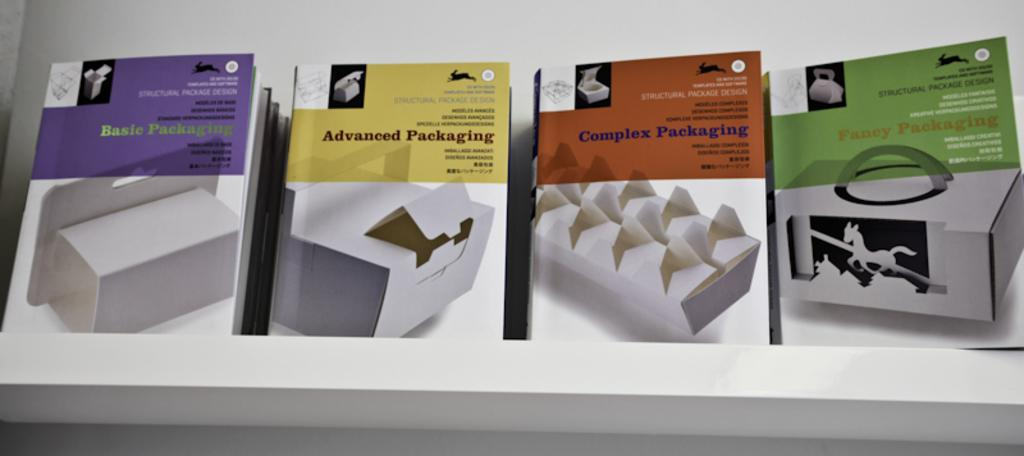<image>
Summarize the visual content of the image. A row of material pertaining to packing starting with basic packaging and ending with fancy packaging. 